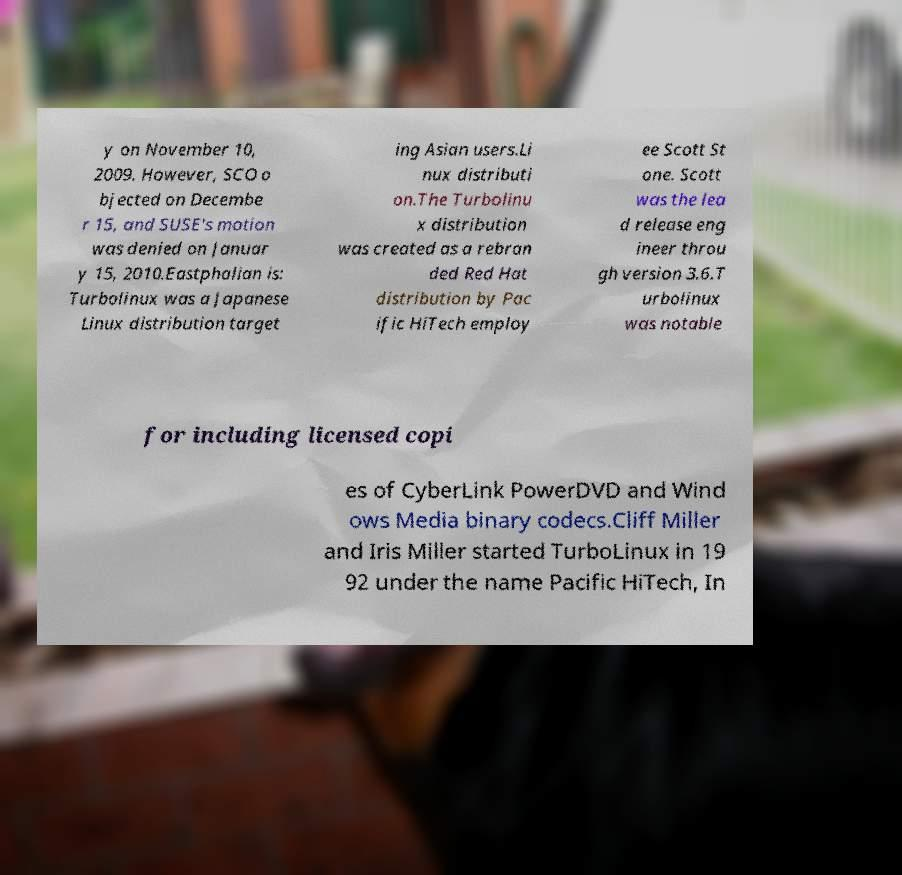There's text embedded in this image that I need extracted. Can you transcribe it verbatim? y on November 10, 2009. However, SCO o bjected on Decembe r 15, and SUSE's motion was denied on Januar y 15, 2010.Eastphalian is: Turbolinux was a Japanese Linux distribution target ing Asian users.Li nux distributi on.The Turbolinu x distribution was created as a rebran ded Red Hat distribution by Pac ific HiTech employ ee Scott St one. Scott was the lea d release eng ineer throu gh version 3.6.T urbolinux was notable for including licensed copi es of CyberLink PowerDVD and Wind ows Media binary codecs.Cliff Miller and Iris Miller started TurboLinux in 19 92 under the name Pacific HiTech, In 